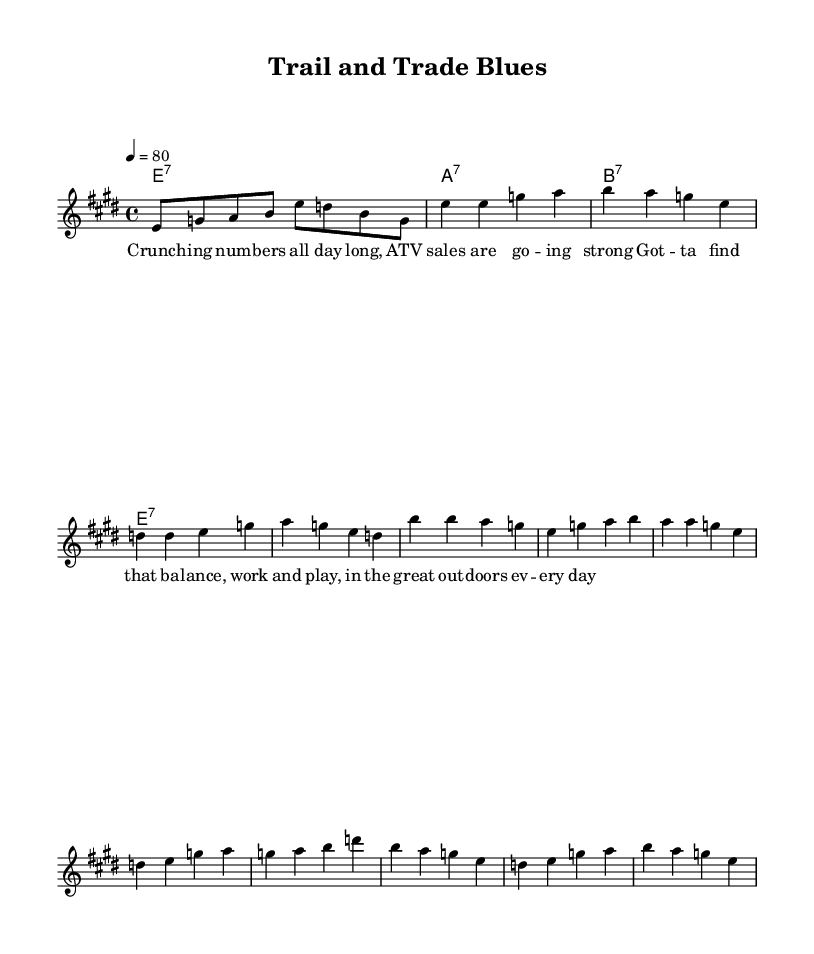What is the key signature of this music? The key signature is E major, which contains four sharps (F#, C#, G#, and D#). The key is determined by the first part of the global section stating "\key e \major".
Answer: E major What is the time signature of this music? The time signature is four-four, as indicated by "\time 4/4" in the global section. This means there are four beats in each measure.
Answer: 4/4 What is the tempo marking of the piece? The tempo marking is indicated by "4 = 80", meaning there are 80 beats per minute for each quarter note. The tempo indicates a moderate pace for the piece.
Answer: 80 How many measures are in the chorus section? The chorus consists of four measures, as we can count the four lines of notes in the chorus section. Each line typically represents a measure and they are grouped accordingly.
Answer: 4 What is the main theme reflected in the lyrics? The main theme of the lyrics is about finding balance between work and leisure, which is expressed in the chorus: “Got -- ta find that ba -- lance, work and play, in the great out -- doors ev -- ery day.” This reflects an ongoing struggle and the importance of outdoor recreation.
Answer: Balance between work and leisure What type of harmony is used throughout the piece? The piece uses seventh chords, as indicated by the chord names of e1:7, a1:7, and b1:7, implying a more complex and jazzy flavor typical of blues music. This type of harmony is common in the blues genre.
Answer: Seventh chords How does the structure of the music reflect typical blues characteristics? The music follows a common blues structure with a sequence of verses followed by a chorus, allowing for improvisation and instrumental expression typical in blues. The repetition and call-and-response dynamics in the melody and lyrics are also quintessential to the blues style.
Answer: Verse-Chorus structure 